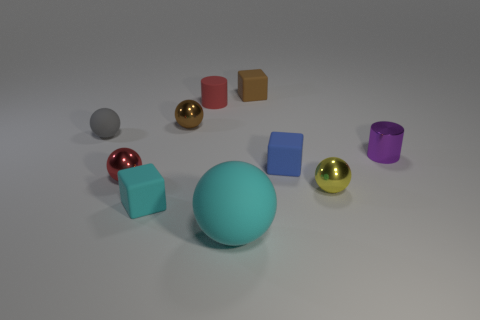What could be the purpose of the arrangement of these objects? This arrangement of objects could be for multiple purposes. If this is an artistic composition, it might be designed to explore geometric shapes and colors. If it's an educational image, it could serve to teach about shapes, shading, and perspectives in three-dimensional space. Alternatively, it could simply be a random assortment with no intended purpose beyond visual interest. 